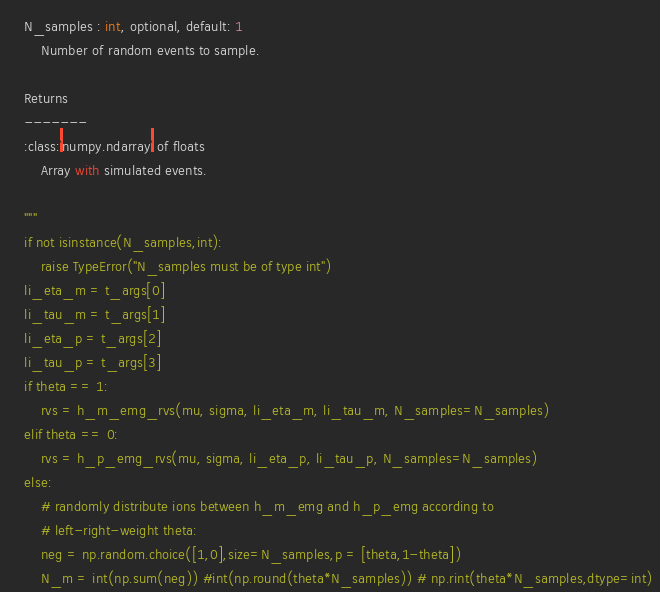<code> <loc_0><loc_0><loc_500><loc_500><_Python_>    N_samples : int, optional, default: 1
        Number of random events to sample.

    Returns
    -------
    :class:`numpy.ndarray` of floats
        Array with simulated events.

    """
    if not isinstance(N_samples,int):
        raise TypeError("N_samples must be of type int")
    li_eta_m = t_args[0]
    li_tau_m = t_args[1]
    li_eta_p = t_args[2]
    li_tau_p = t_args[3]
    if theta == 1:
        rvs = h_m_emg_rvs(mu, sigma, li_eta_m, li_tau_m, N_samples=N_samples)
    elif theta == 0:
        rvs = h_p_emg_rvs(mu, sigma, li_eta_p, li_tau_p, N_samples=N_samples)
    else:
        # randomly distribute ions between h_m_emg and h_p_emg according to
        # left-right-weight theta:
        neg = np.random.choice([1,0],size=N_samples,p = [theta,1-theta])
        N_m = int(np.sum(neg)) #int(np.round(theta*N_samples)) # np.rint(theta*N_samples,dtype=int)</code> 